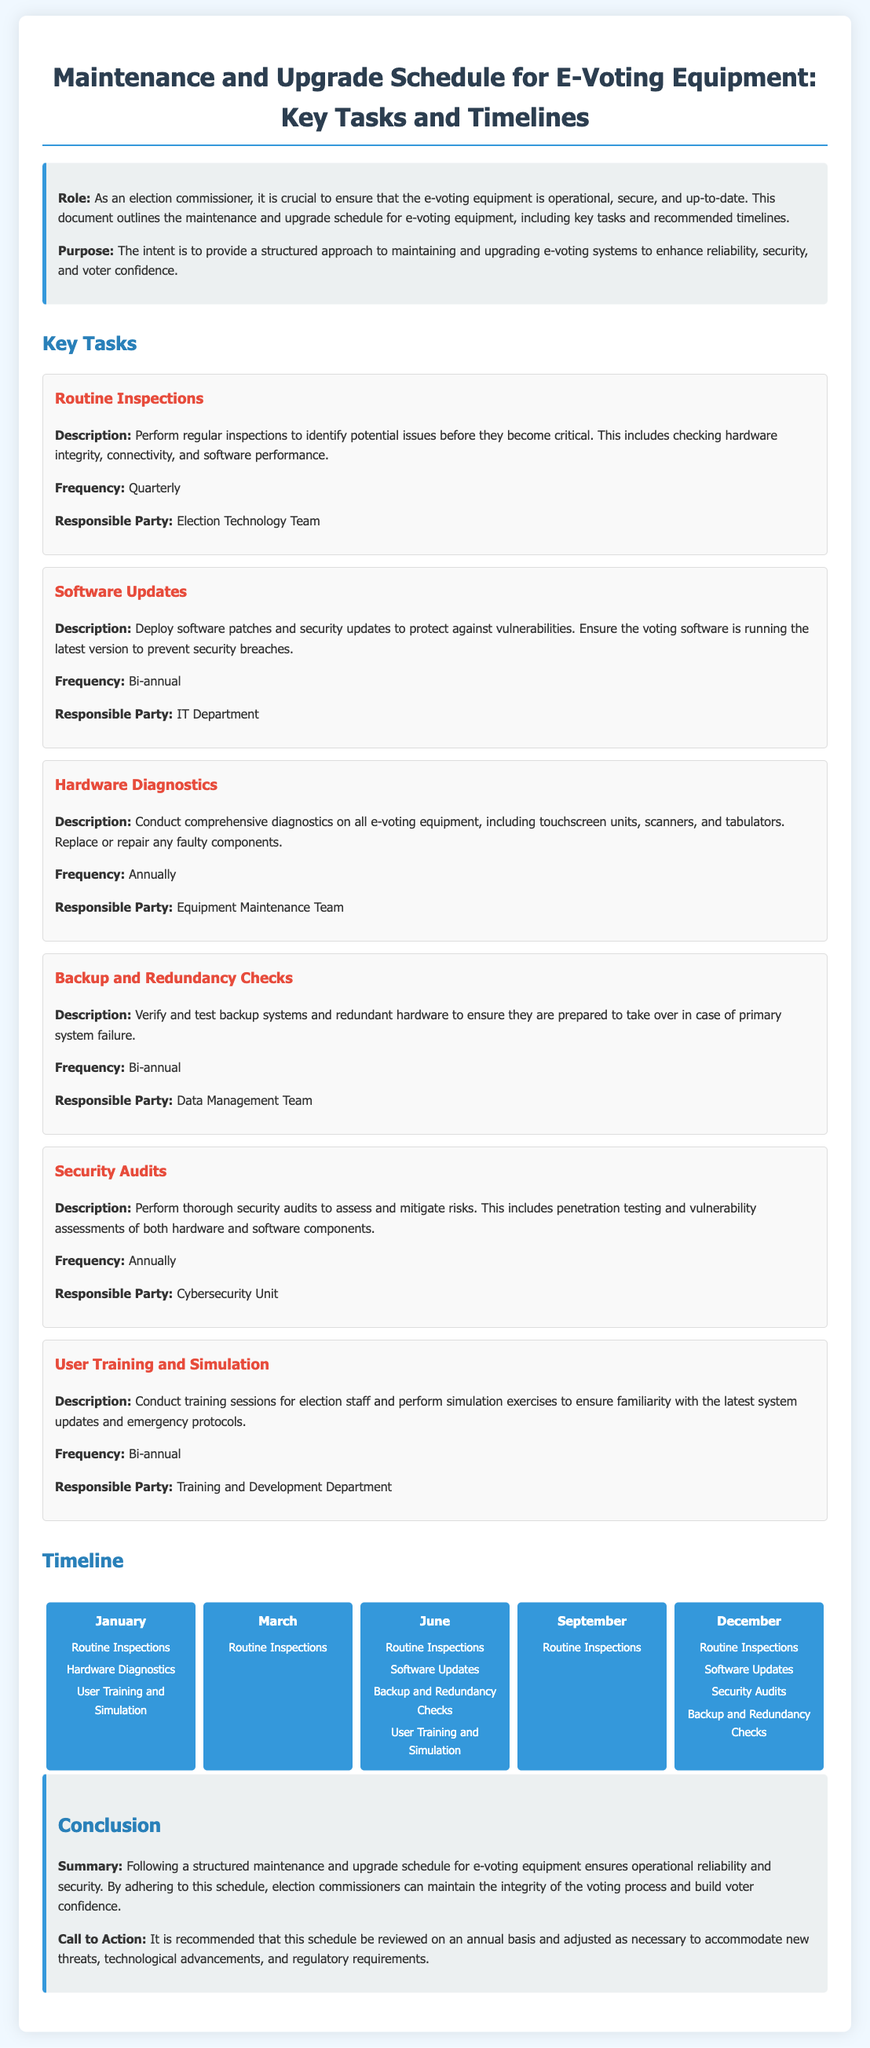What is the purpose of the document? The purpose is to provide a structured approach to maintaining and upgrading e-voting systems to enhance reliability, security, and voter confidence.
Answer: To provide a structured approach What task is performed quarterly? The document states that routine inspections are performed to identify potential issues.
Answer: Routine Inspections Who is responsible for software updates? The responsible party for software updates according to the document is the IT Department.
Answer: IT Department How often are security audits conducted? The document indicates that security audits are conducted annually.
Answer: Annually Which month has hardware diagnostics scheduled? The document specifies that hardware diagnostics are scheduled for January.
Answer: January What is the frequency for user training and simulation? The frequency for conducting user training and simulation sessions is bi-annual as per the document.
Answer: Bi-annual What type of audits assess and mitigate risks? The document specifies that security audits are performed to assess and mitigate risks.
Answer: Security Audits In which month are both security audits and software updates scheduled? The document shows that both security audits and software updates are scheduled for December.
Answer: December What is the concluding recommendation regarding the schedule? The concluding recommendation is that this schedule should be reviewed on an annual basis and adjusted as necessary.
Answer: Reviewed on an annual basis 